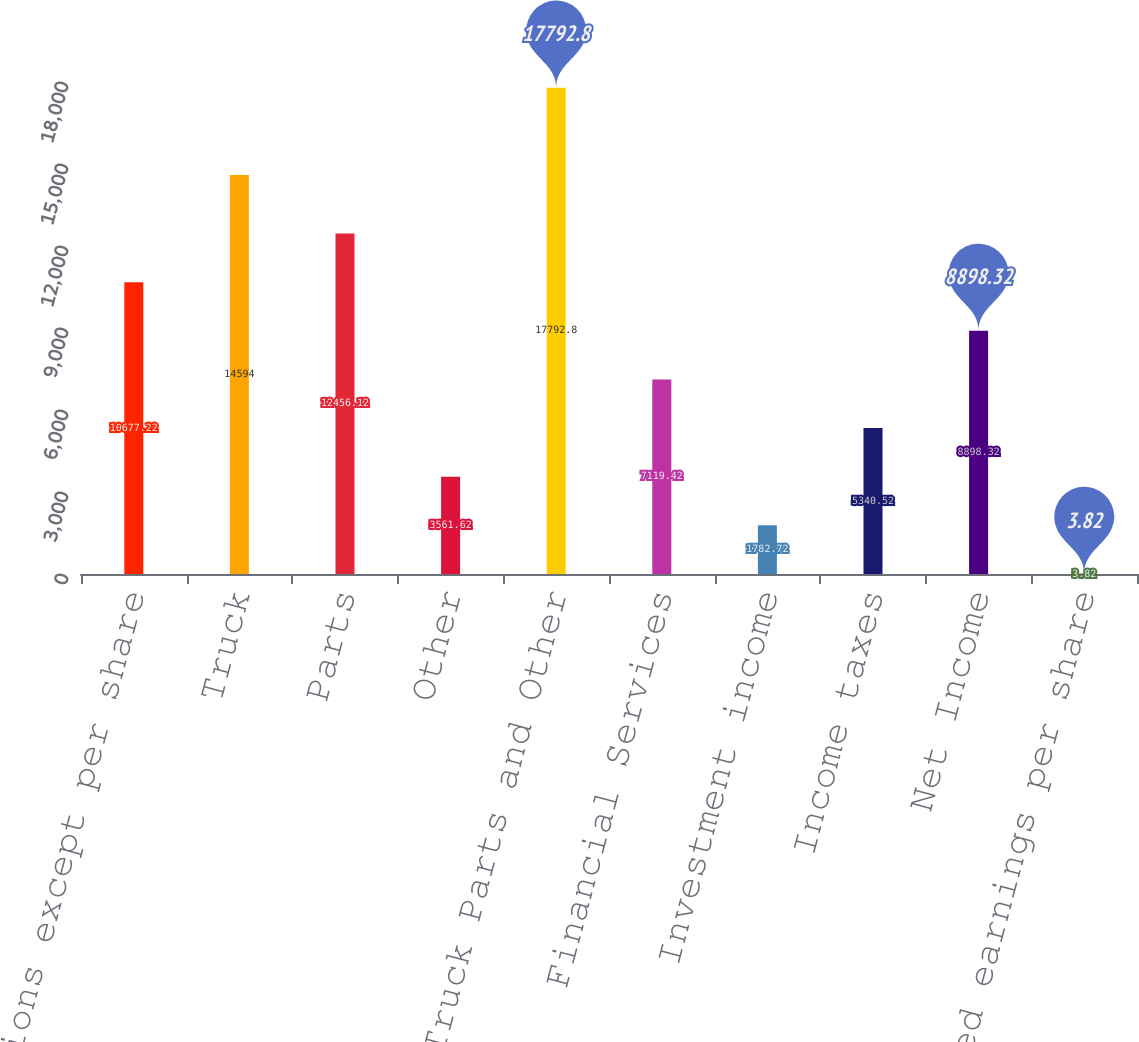<chart> <loc_0><loc_0><loc_500><loc_500><bar_chart><fcel>( in millions except per share<fcel>Truck<fcel>Parts<fcel>Other<fcel>Truck Parts and Other<fcel>Financial Services<fcel>Investment income<fcel>Income taxes<fcel>Net Income<fcel>Diluted earnings per share<nl><fcel>10677.2<fcel>14594<fcel>12456.1<fcel>3561.62<fcel>17792.8<fcel>7119.42<fcel>1782.72<fcel>5340.52<fcel>8898.32<fcel>3.82<nl></chart> 